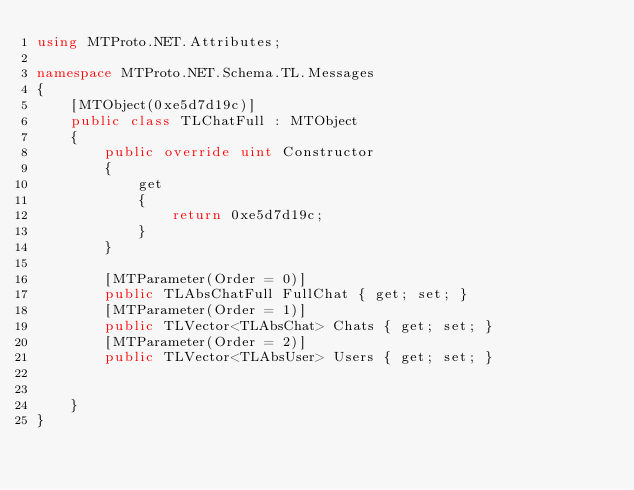Convert code to text. <code><loc_0><loc_0><loc_500><loc_500><_C#_>using MTProto.NET.Attributes;

namespace MTProto.NET.Schema.TL.Messages
{
    [MTObject(0xe5d7d19c)]
    public class TLChatFull : MTObject
    {
        public override uint Constructor
        {
            get
            {
                return 0xe5d7d19c;
            }
        }

        [MTParameter(Order = 0)]
        public TLAbsChatFull FullChat { get; set; }
        [MTParameter(Order = 1)]
        public TLVector<TLAbsChat> Chats { get; set; }
        [MTParameter(Order = 2)]
        public TLVector<TLAbsUser> Users { get; set; }


    }
}
</code> 